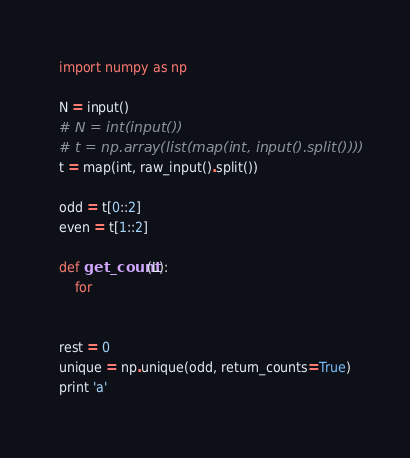Convert code to text. <code><loc_0><loc_0><loc_500><loc_500><_Python_>import numpy as np

N = input()
# N = int(input())
# t = np.array(list(map(int, input().split())))
t = map(int, raw_input().split())

odd = t[0::2]
even = t[1::2]

def get_count(L):
    for 


rest = 0
unique = np.unique(odd, return_counts=True)
print 'a'</code> 